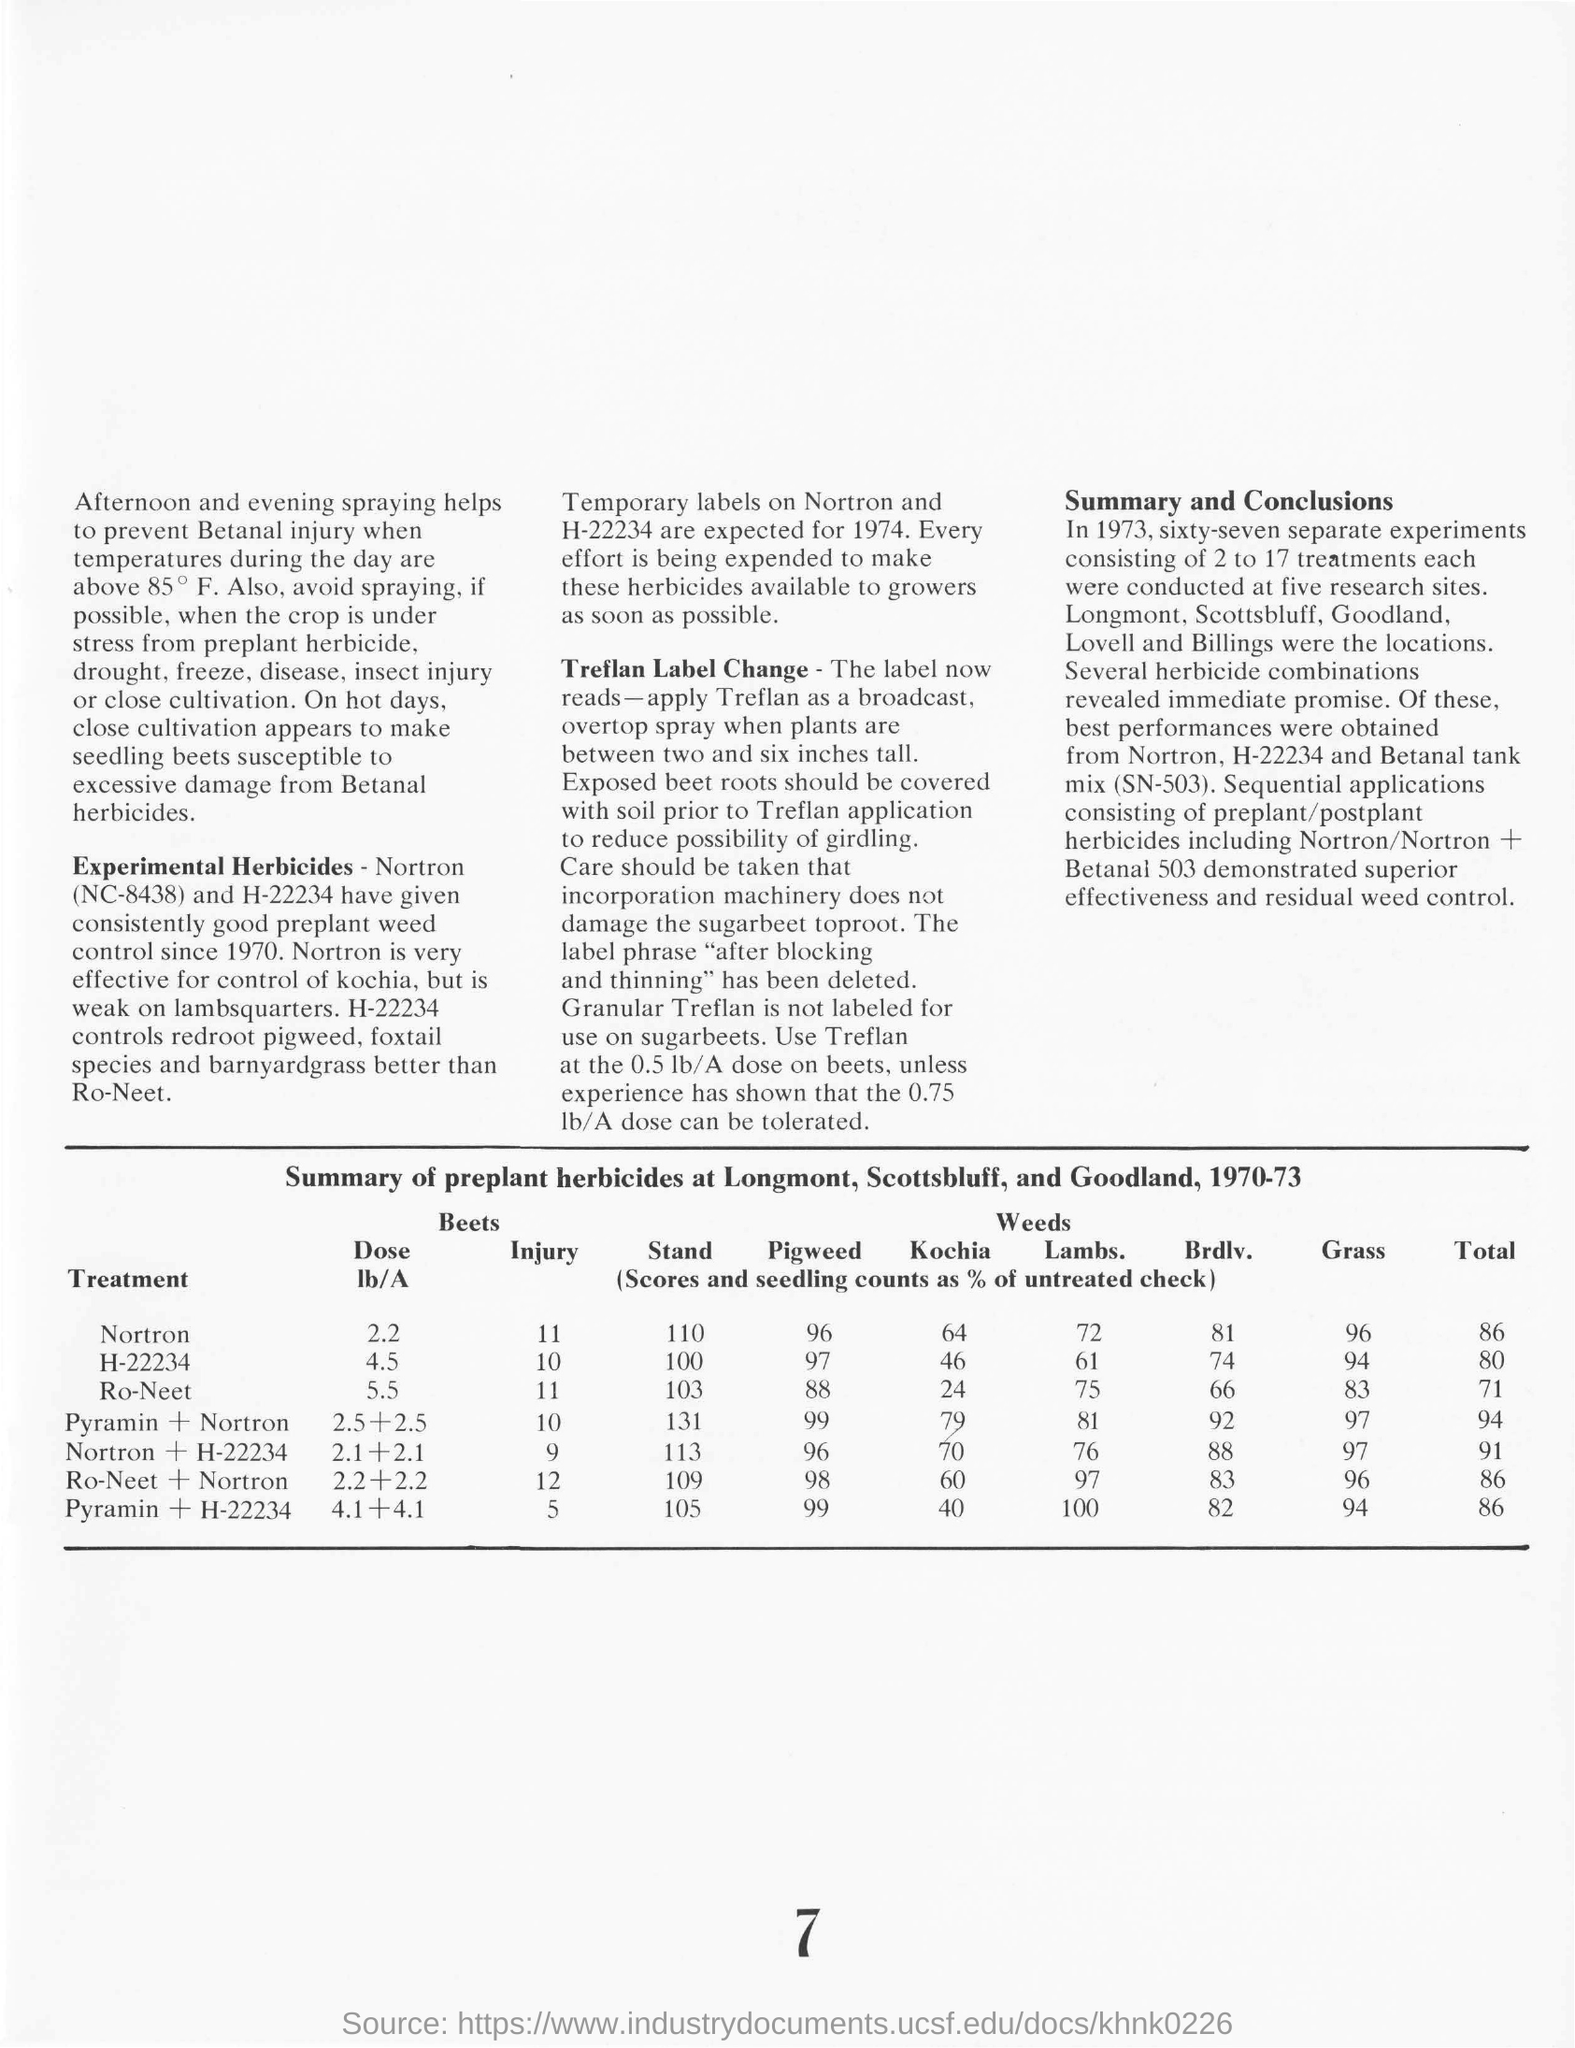Outline some significant characteristics in this image. The total for Nortron is 86. The injury number assigned to Ro-Neet is 11. After blocking and thinning, the label phrase was deleted. 